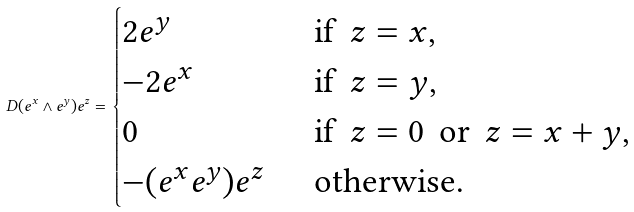<formula> <loc_0><loc_0><loc_500><loc_500>D ( e ^ { x } \wedge e ^ { y } ) e ^ { z } = \begin{cases} 2 e ^ { y } & \text {\, if \,} z = x , \\ - 2 e ^ { x } & \text {\, if \,} z = y , \\ 0 & \text {\, if \,} z = 0 \text {\, or \,} z = x + y , \\ - ( e ^ { x } e ^ { y } ) e ^ { z } & \text {\, otherwise} . \end{cases}</formula> 